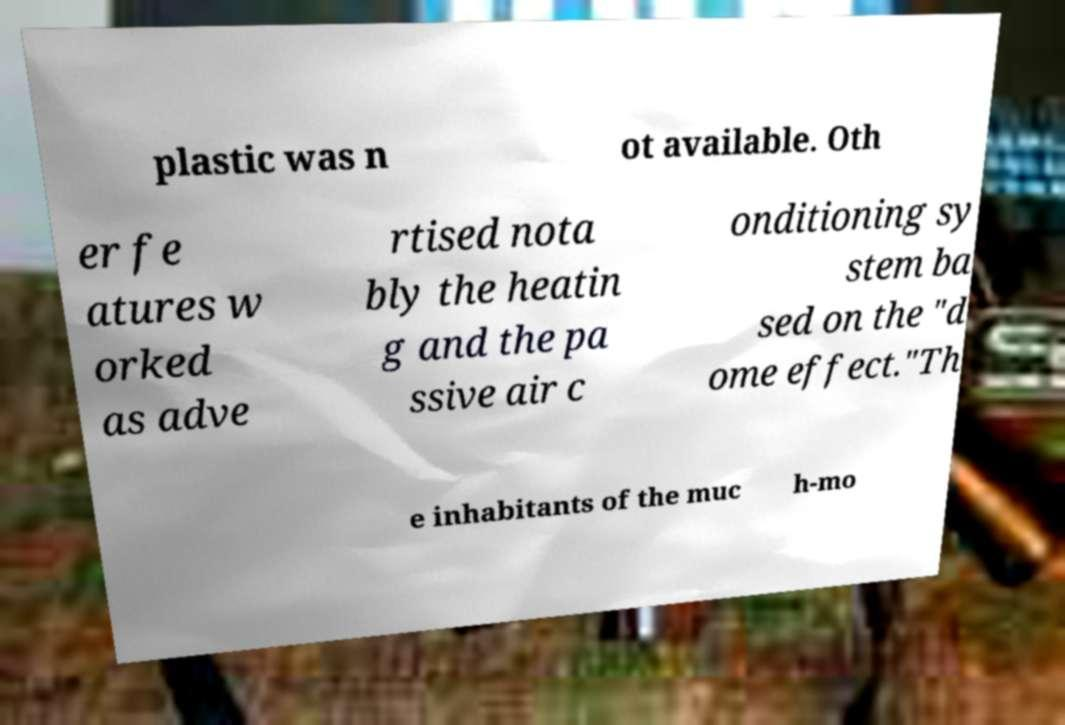There's text embedded in this image that I need extracted. Can you transcribe it verbatim? plastic was n ot available. Oth er fe atures w orked as adve rtised nota bly the heatin g and the pa ssive air c onditioning sy stem ba sed on the "d ome effect."Th e inhabitants of the muc h-mo 